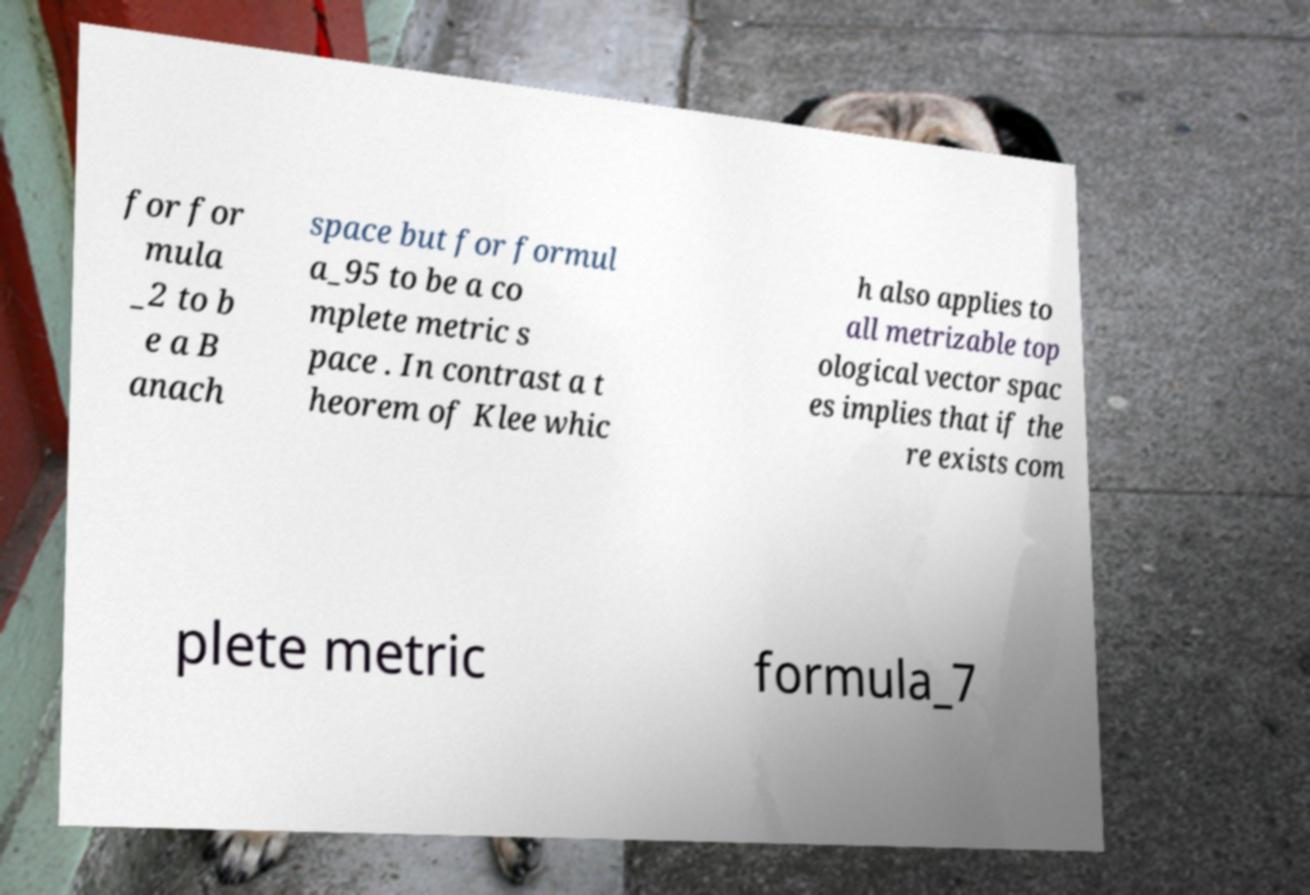Could you extract and type out the text from this image? for for mula _2 to b e a B anach space but for formul a_95 to be a co mplete metric s pace . In contrast a t heorem of Klee whic h also applies to all metrizable top ological vector spac es implies that if the re exists com plete metric formula_7 